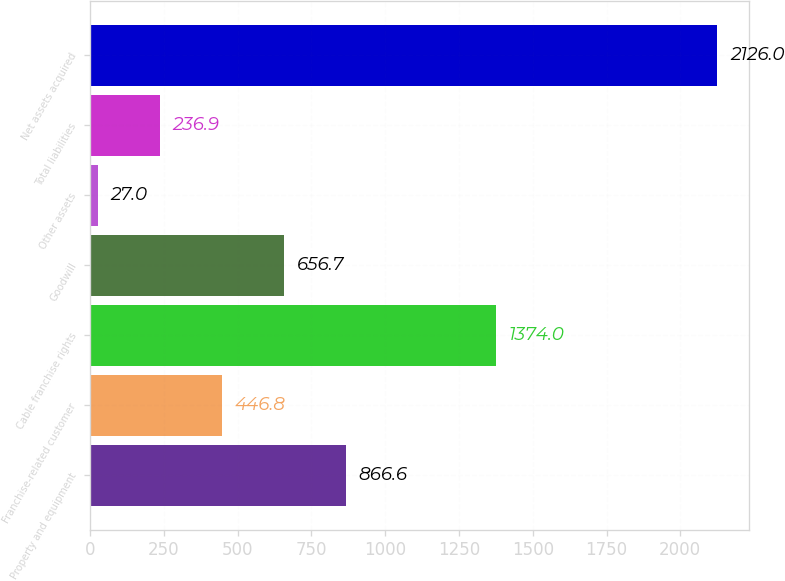<chart> <loc_0><loc_0><loc_500><loc_500><bar_chart><fcel>Property and equipment<fcel>Franchise-related customer<fcel>Cable franchise rights<fcel>Goodwill<fcel>Other assets<fcel>Total liabilities<fcel>Net assets acquired<nl><fcel>866.6<fcel>446.8<fcel>1374<fcel>656.7<fcel>27<fcel>236.9<fcel>2126<nl></chart> 